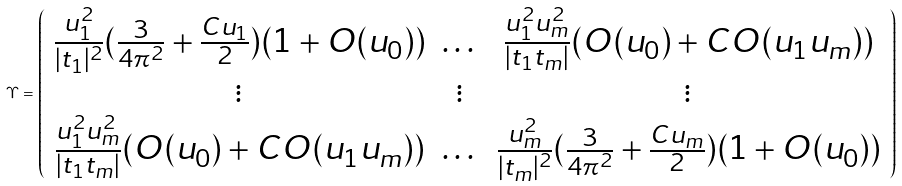Convert formula to latex. <formula><loc_0><loc_0><loc_500><loc_500>\Upsilon = \left ( \begin{array} { c c c } \frac { u _ { 1 } ^ { 2 } } { | t _ { 1 } | ^ { 2 } } ( \frac { 3 } { 4 \pi ^ { 2 } } + \frac { C u _ { 1 } } { 2 } ) ( 1 + O ( u _ { 0 } ) ) & \dots & \frac { u _ { 1 } ^ { 2 } u _ { m } ^ { 2 } } { | t _ { 1 } t _ { m } | } ( O ( u _ { 0 } ) + C O ( u _ { 1 } u _ { m } ) ) \\ \vdots & \vdots & \vdots \\ \frac { u _ { 1 } ^ { 2 } u _ { m } ^ { 2 } } { | t _ { 1 } t _ { m } | } ( O ( u _ { 0 } ) + C O ( u _ { 1 } u _ { m } ) ) & \dots & \frac { u _ { m } ^ { 2 } } { | t _ { m } | ^ { 2 } } ( \frac { 3 } { 4 \pi ^ { 2 } } + \frac { C u _ { m } } { 2 } ) ( 1 + O ( u _ { 0 } ) ) \end{array} \right )</formula> 